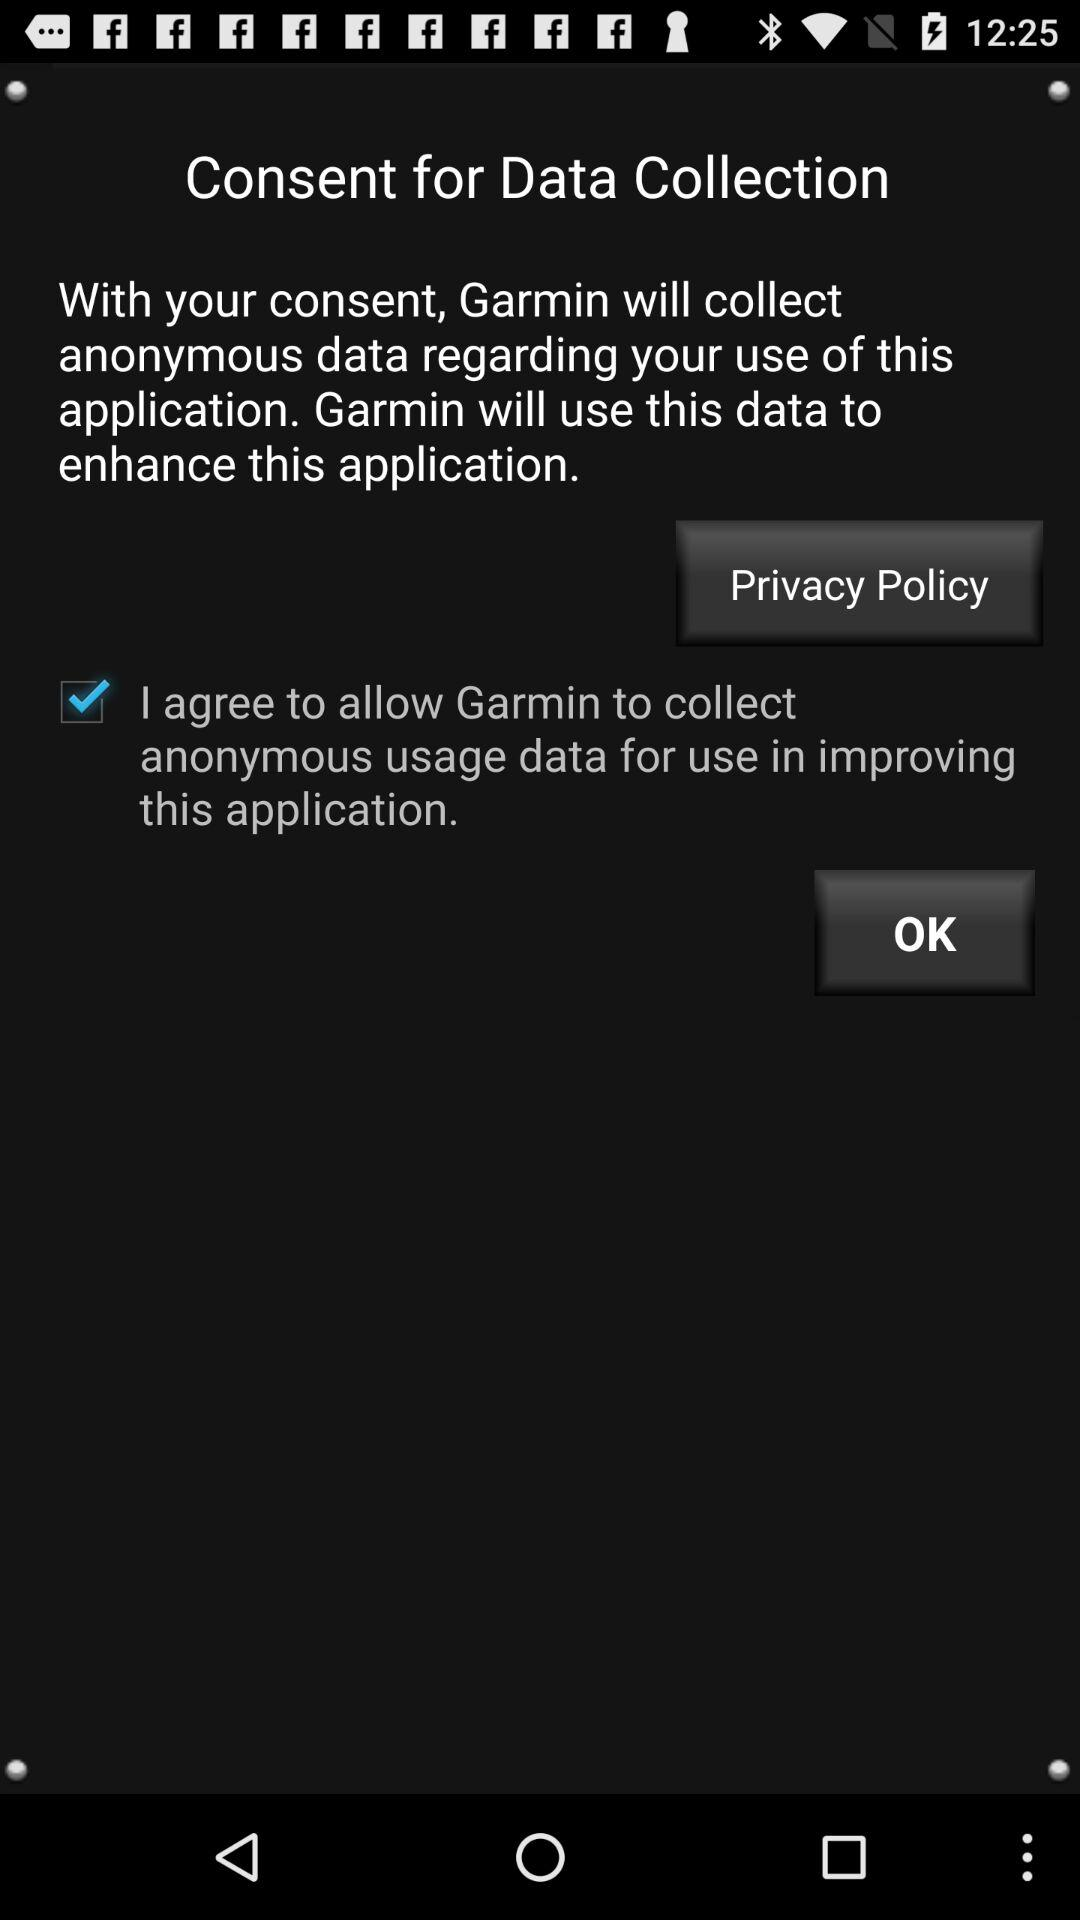What is the status of "I agree to allow Garmin"? The status is "on". 